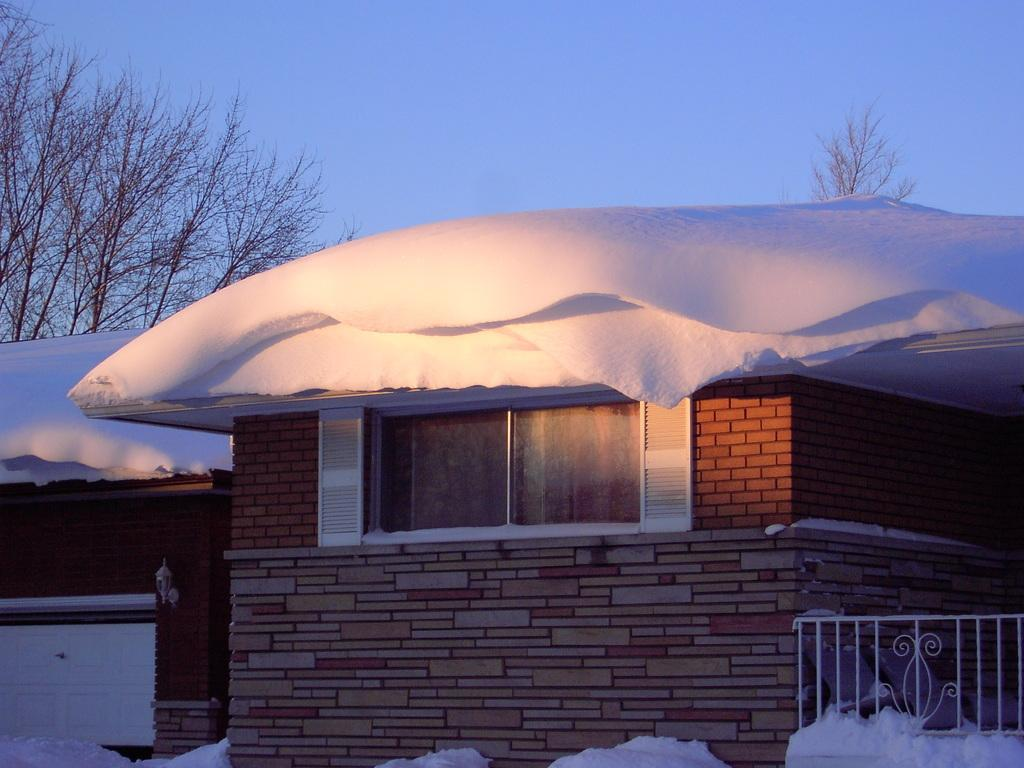What type of structures can be seen in the image? There are houses in the image. What other natural elements are present in the image? There are trees in the image. What is the weather condition in the image? There is snow visible in the image. Can you describe any man-made objects in the image? There are metal rods at the right bottom of the image. Where is the river flowing in the image? There is no river present in the image. What type of camera is being used to take the picture? The image does not provide any information about the camera used to take the picture. 